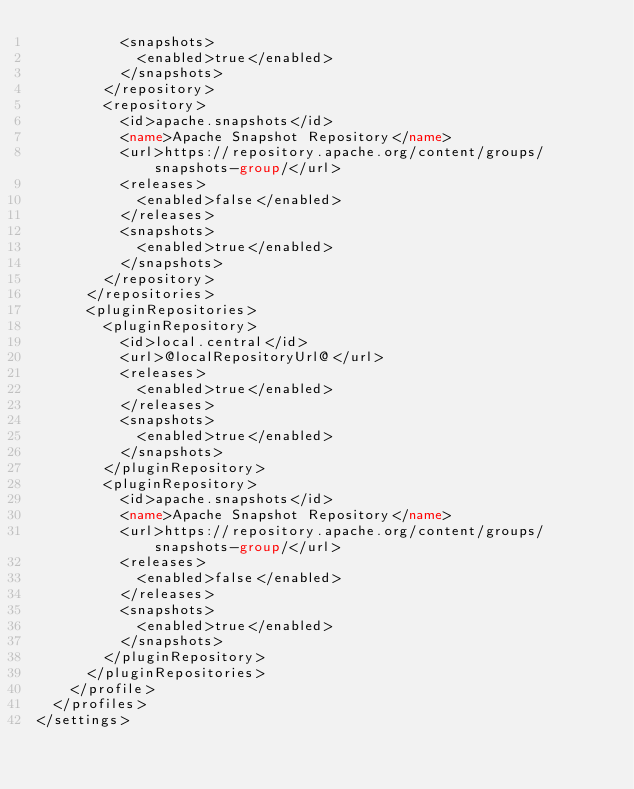Convert code to text. <code><loc_0><loc_0><loc_500><loc_500><_XML_>          <snapshots>
            <enabled>true</enabled>
          </snapshots>
        </repository>
        <repository>
          <id>apache.snapshots</id>
          <name>Apache Snapshot Repository</name>
          <url>https://repository.apache.org/content/groups/snapshots-group/</url>
          <releases>
            <enabled>false</enabled>
          </releases>
          <snapshots>
            <enabled>true</enabled>
          </snapshots>
        </repository>    
      </repositories>
      <pluginRepositories>
        <pluginRepository>
          <id>local.central</id>
          <url>@localRepositoryUrl@</url>
          <releases>
            <enabled>true</enabled>
          </releases>
          <snapshots>
            <enabled>true</enabled>
          </snapshots>
        </pluginRepository>
        <pluginRepository>
          <id>apache.snapshots</id>
          <name>Apache Snapshot Repository</name>
          <url>https://repository.apache.org/content/groups/snapshots-group/</url>
          <releases>
            <enabled>false</enabled>
          </releases>
          <snapshots>
            <enabled>true</enabled>
          </snapshots>
        </pluginRepository>         
      </pluginRepositories>
    </profile>
  </profiles>
</settings>
</code> 